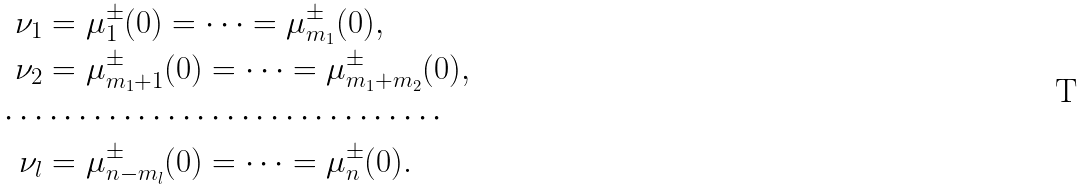Convert formula to latex. <formula><loc_0><loc_0><loc_500><loc_500>\nu _ { 1 } & = \mu _ { 1 } ^ { \pm } ( 0 ) = \cdots = \mu _ { m _ { 1 } } ^ { \pm } ( 0 ) , \\ \nu _ { 2 } & = \mu _ { m _ { 1 } + 1 } ^ { \pm } ( 0 ) = \cdots = \mu _ { m _ { 1 } + m _ { 2 } } ^ { \pm } ( 0 ) , \\ \cdots & \cdots \cdots \cdots \cdots \cdots \cdots \cdots \cdots \cdots \\ \nu _ { l } & = \mu _ { n - m _ { l } } ^ { \pm } ( 0 ) = \cdots = \mu _ { n } ^ { \pm } ( 0 ) .</formula> 